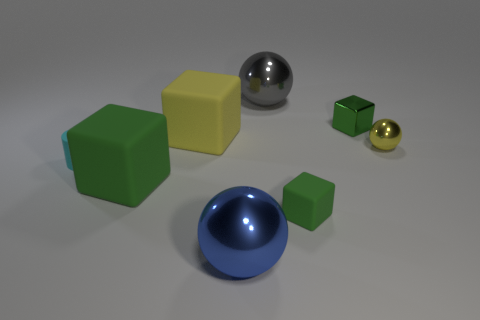Subtract all green blocks. How many blocks are left? 1 Subtract all red cylinders. How many green cubes are left? 3 Add 2 small yellow things. How many objects exist? 10 Subtract all green blocks. How many blocks are left? 1 Subtract all balls. How many objects are left? 5 Subtract all brown spheres. Subtract all brown cylinders. How many spheres are left? 3 Subtract 2 spheres. How many spheres are left? 1 Subtract all large brown metal objects. Subtract all metallic blocks. How many objects are left? 7 Add 4 small yellow metal objects. How many small yellow metal objects are left? 5 Add 4 matte cubes. How many matte cubes exist? 7 